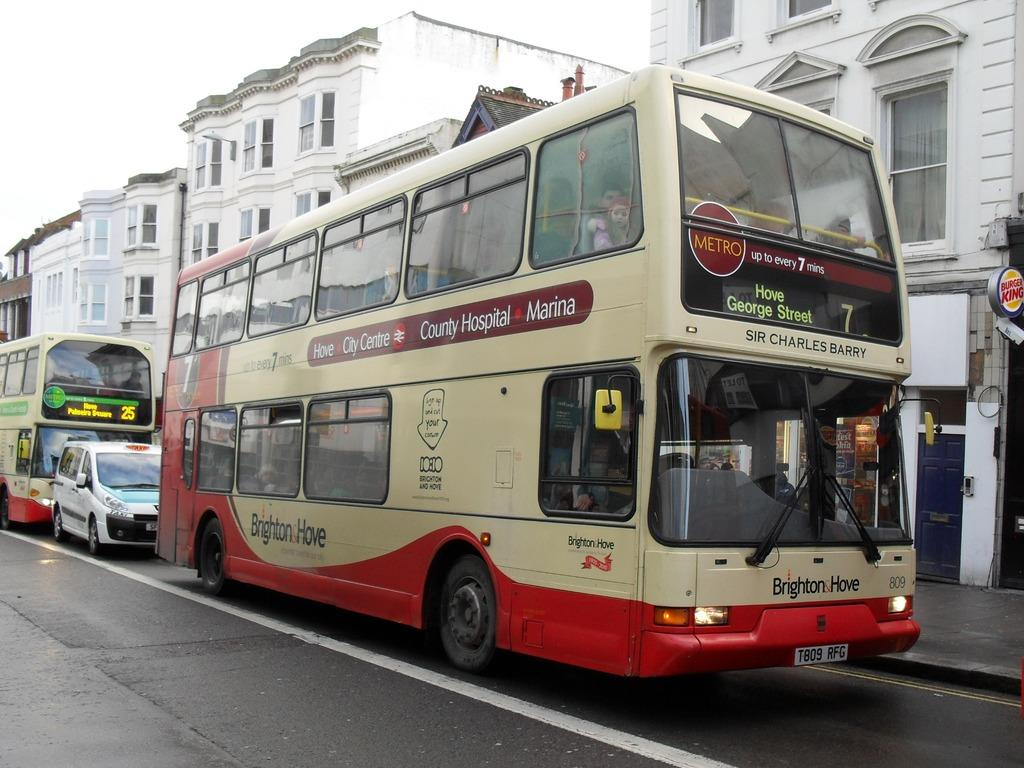<image>
Give a short and clear explanation of the subsequent image. The two decker number 7 bus is ahead of the two decker number 25 bus. 